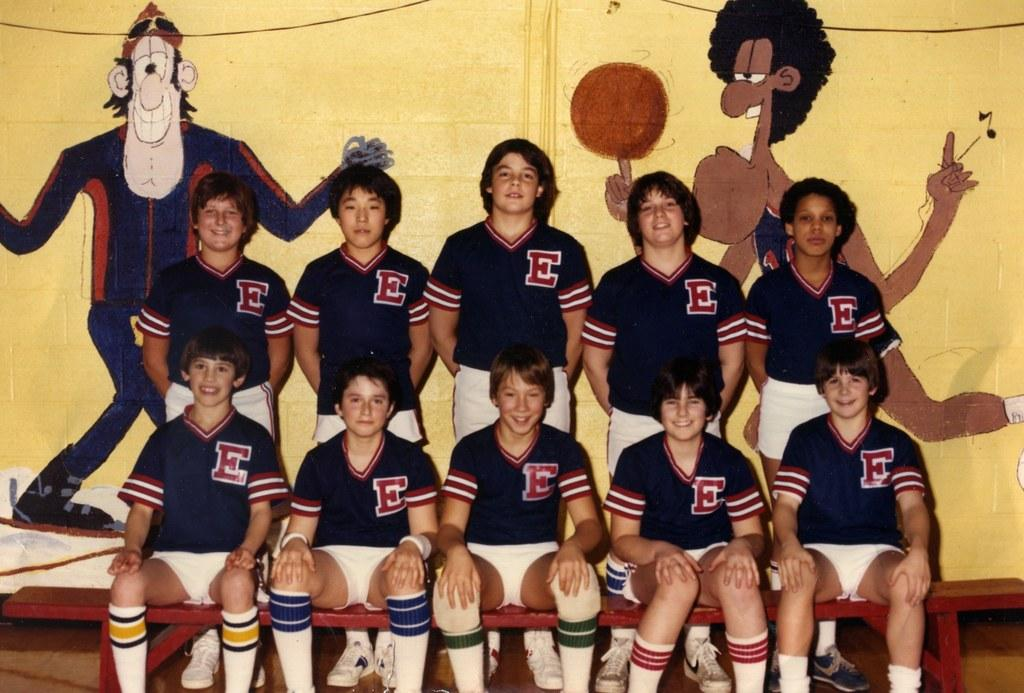Provide a one-sentence caption for the provided image. A sports team wearing jerseys that have a big E on them. 